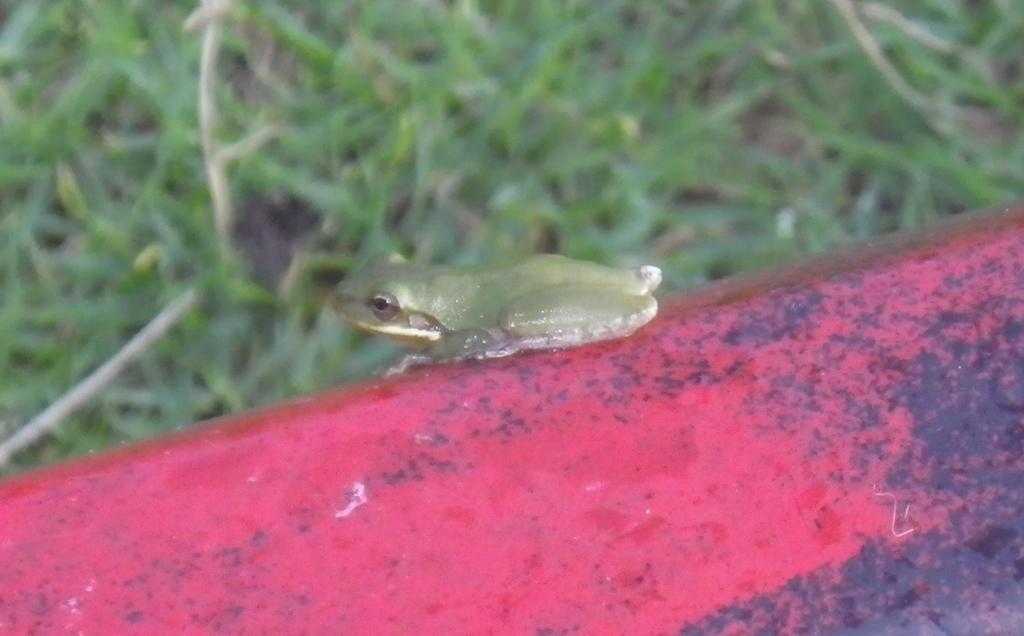Could you give a brief overview of what you see in this image? In the center of the image, we can see a frog which is on the rod and in the background, there are plants. 